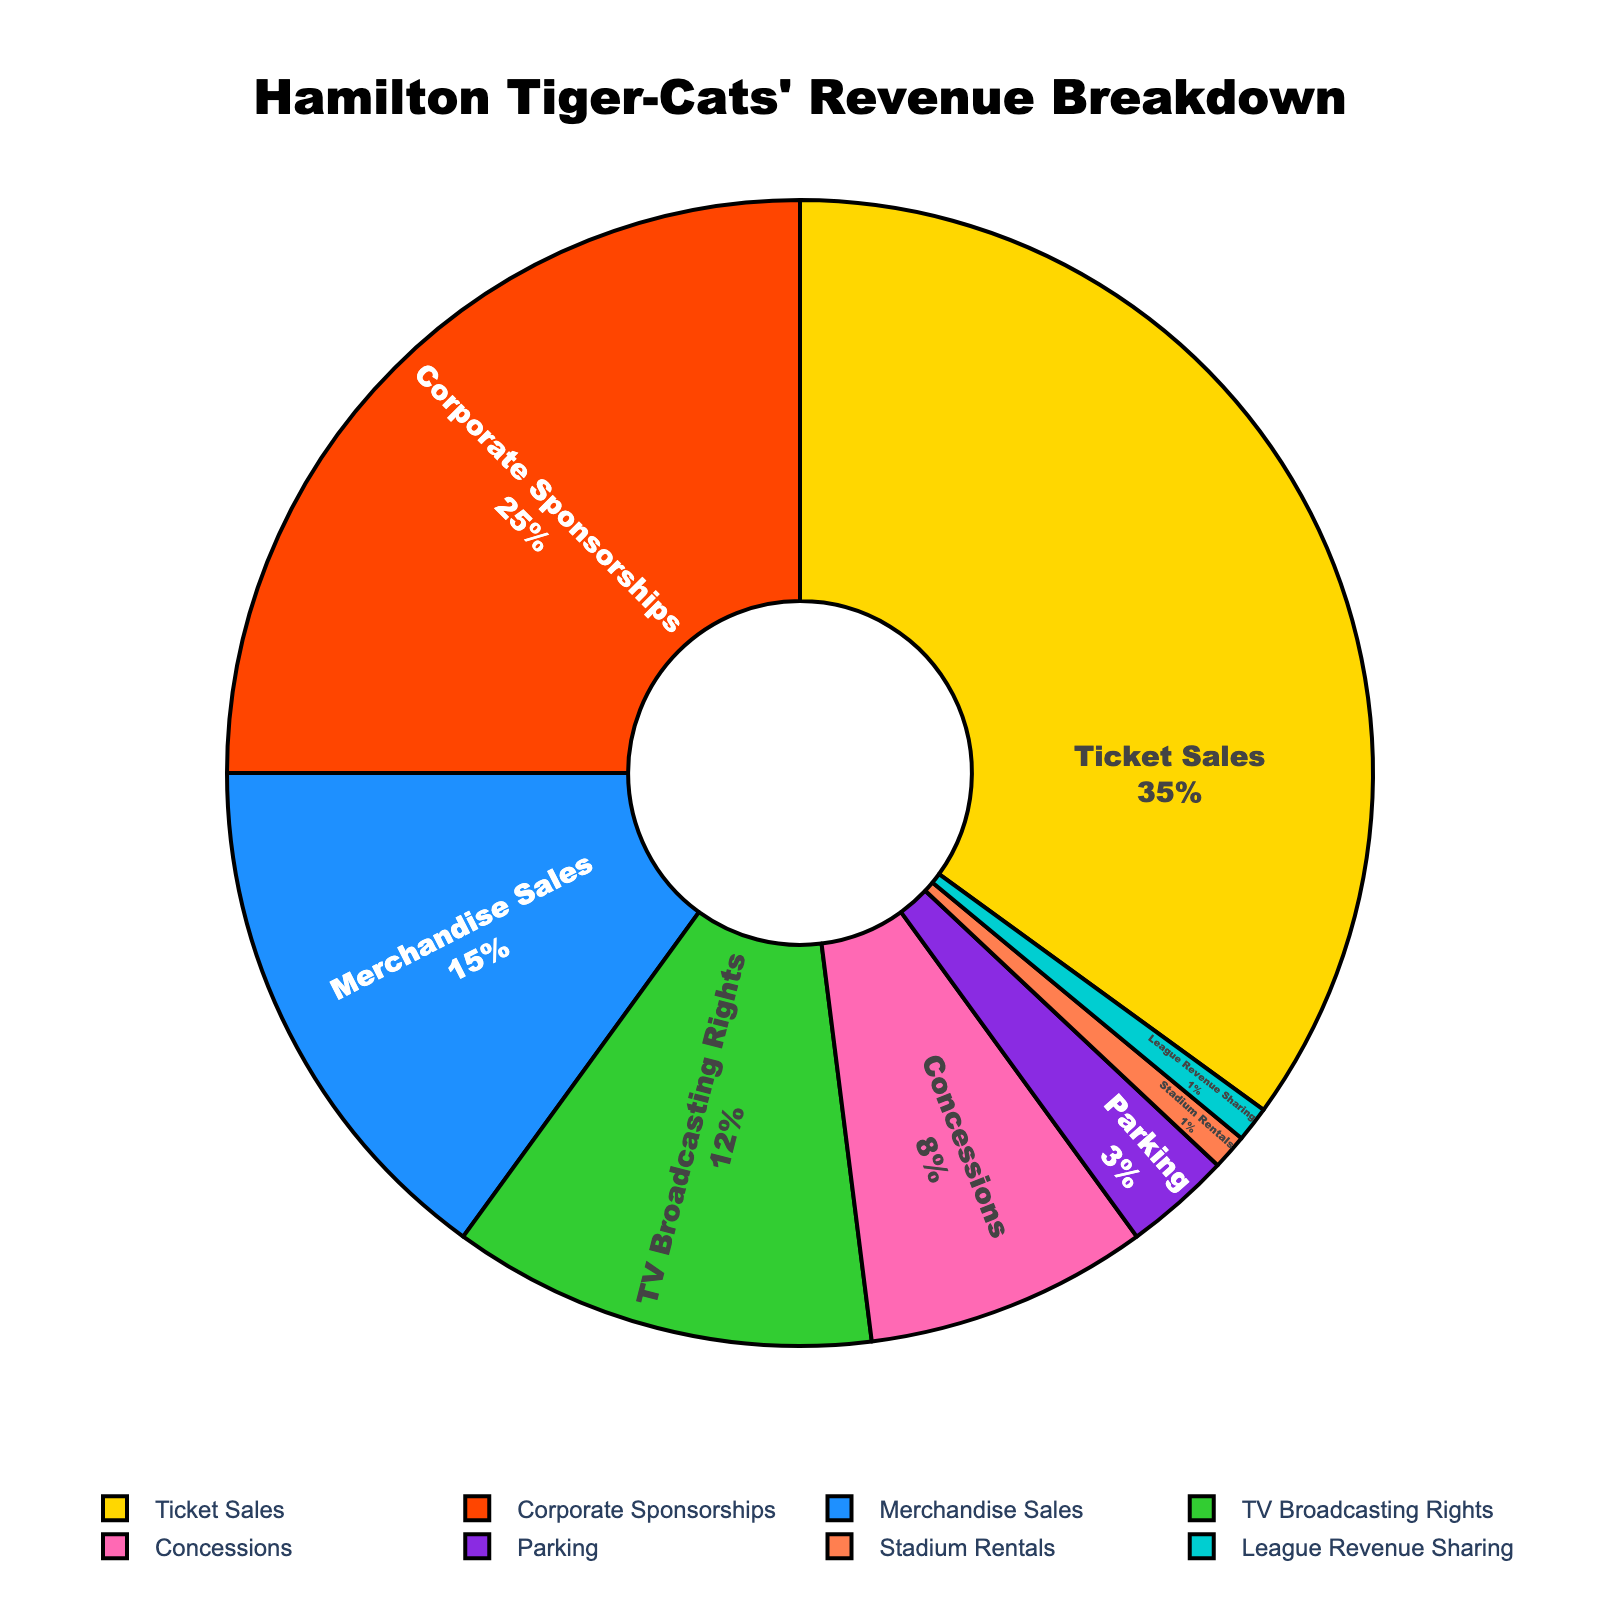What is the percentage contribution of Ticket Sales and Corporate Sponsorships combined? First, identify the percentage of Ticket Sales (35%) and Corporate Sponsorships (25%) from the figure. Then, sum these two percentages: 35% + 25% = 60%
Answer: 60% Which revenue source has the smallest contribution? Look for the segment with the smallest percentage. The smallest contribution is 1%, shared by both Stadium Rentals and League Revenue Sharing
Answer: Stadium Rentals and League Revenue Sharing How much greater is the percentage of Merchandise Sales compared to Parking? Identify the percentages of Merchandise Sales (15%) and Parking (3%). Then subtract the smaller percentage from the larger one: 15% - 3% = 12%
Answer: 12% What is the cumulative percentage of Concessions, Parking, Stadium Rentals, and League Revenue Sharing? Sum the percentages of Concessions (8%), Parking (3%), Stadium Rentals (1%), and League Revenue Sharing (1%): 8% + 3% + 1% + 1% = 13%
Answer: 13% Which category, Merchandise Sales or TV Broadcasting Rights, contributes more to the revenue, and by how much? Identify the percentages of Merchandise Sales (15%) and TV Broadcasting Rights (12%). Then calculate the difference: 15% - 12% = 3%
Answer: Merchandise Sales by 3% Which color segment represents the Concessions revenue source in the pie chart? Identify the Concessions segment (8%) by its color in the pie chart. According to the color list, Concessions is represented by pink
Answer: Pink Which three revenue sources combined represent half of the total revenue? Identify the three largest segments: Ticket Sales (35%), Corporate Sponsorships (25%), and Merchandise Sales (15%). Check if their sum equals half of the total revenue: 35% + 25% + 15% = 75%. This is too high, so try other combinations. Ticket Sales (35%), Corporate Sponsorships (25%), and TV Broadcasting Rights (12%): 35% + 25% + 12% = 72%, still too high. Trying Ticket Sales (35%), Corporate Sponsorships (25%), and Concessions (8%): 35% + 25% + 8% = 68%. Finally, Ticket Sales (35%), Corporate Sponsorships (25%), and Merchandise Sales (15%) sums to 75%. Just Corporate Sponsorships (25%), Merchandise Sales (15%), and TV Broadcasting Rights (12%): 25% + 15% + 12% = 52%
Answer: TV Broadcasting Rights, Merchandise Sales, and Concessions What is the average percentage of League Revenue Sharing and Stadium Rentals? Sum the percentages of League Revenue Sharing (1%) and Stadium Rentals (1%), then divide by 2 to get the average: (1% + 1%) / 2 = 1%
Answer: 1% Is the combined contribution of TV Broadcasting Rights and Parking greater or less than Corporate Sponsorships? Identify the percentages of TV Broadcasting Rights (12%) and Parking (3%), then sum them: 12% + 3% = 15%. Compare this to Corporate Sponsorships (25%): 15% < 25%
Answer: Less What is the difference between the percentages of the largest and smallest revenue sources? Identify the largest revenue source (Ticket Sales, 35%) and smallest revenue sources (Stadium Rentals and League Revenue Sharing, each 1%). Subtract the smallest from the largest: 35% - 1% = 34%
Answer: 34% 